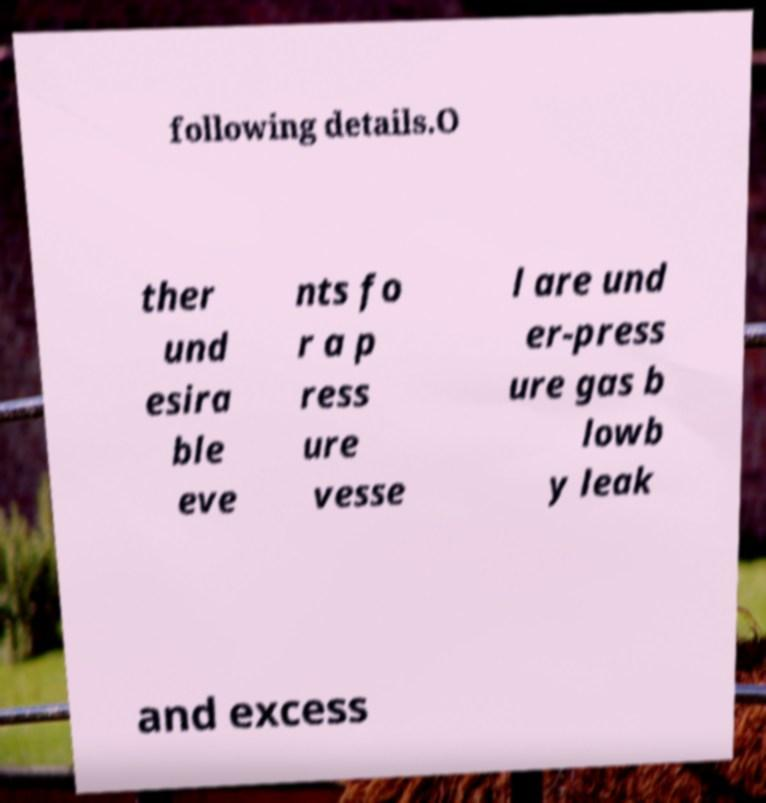Can you read and provide the text displayed in the image?This photo seems to have some interesting text. Can you extract and type it out for me? following details.O ther und esira ble eve nts fo r a p ress ure vesse l are und er-press ure gas b lowb y leak and excess 